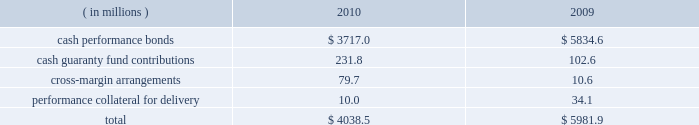Anticipated or possible short-term cash needs , prevailing interest rates , our investment policy and alternative investment choices .
A majority of our cash and cash equivalents balance is invested in money market mutual funds that invest only in u.s .
Treasury securities or u.s .
Government agency securities .
Our exposure to risk is minimal given the nature of the investments .
Our practice is to have our pension plan 100% ( 100 % ) funded at each year end on a projected benefit obligation basis , while also satisfying any minimum required contribution and obtaining the maximum tax deduction .
Based on our actuarial projections , we estimate that a $ 14.1 million contribution in 2011 will allow us to meet our funding goal .
However , the amount of the actual contribution is contingent on the actual rate of return on our plan assets during 2011 and the december 31 , 2011 discount rate .
Net current deferred tax assets of $ 18.3 million and $ 23.8 million are included in other current assets at december 31 , 2010 and 2009 , respectively .
Total net current deferred tax assets include unrealized losses , stock- based compensation and accrued expenses .
Net long-term deferred tax liabilities were $ 7.8 billion and $ 7.6 billion at december 31 , 2010 and 2009 , respectively .
Net deferred tax liabilities are principally the result of purchase accounting for intangible assets in our various mergers including cbot holdings and nymex holdings .
We have a long-term deferred tax asset of $ 145.7 million included within our domestic long-term deferred tax liability .
This deferred tax asset is for an unrealized capital loss incurred in brazil related to our investment in bm&fbovespa .
As of december 31 , 2010 , we do not believe that we currently meet the more-likely-than-not threshold that would allow us to fully realize the value of the unrealized capital loss .
As a result , a partial valuation allowance of $ 64.4 million has been provided for the amount of the unrealized capital loss that exceeds potential capital gains that could be used to offset the capital loss in future periods .
We also have a long-term deferred tax asset related to brazilian taxes of $ 125.3 million for an unrealized capital loss incurred in brazil related to our investment in bm&fbovespa .
A full valuation allowance of $ 125.3 million has been provided because we do not believe that we currently meet the more-likely-than-not threshold that would allow us to realize the value of the unrealized capital loss in brazil in the future .
Valuation allowances of $ 49.4 million have also been provided for additional unrealized capital losses on various other investments .
Net long-term deferred tax assets also include a $ 19.3 million deferred tax asset for foreign net operating losses related to swapstream .
Our assessment at december 31 , 2010 was that we did not currently meet the more-likely- than-not threshold that would allow us to realize the value of acquired and accumulated foreign net operating losses in the future .
As a result , the $ 19.3 million deferred tax assets arising from these net operating losses have been fully reserved .
Each clearing firm is required to deposit and maintain specified performance bond collateral .
Performance bond requirements are determined by parameters established by the risk management department of the clearing house and may fluctuate over time .
We accept a variety of collateral to satisfy performance bond requirements .
Cash performance bonds and guaranty fund contributions are included in our consolidated balance sheets .
Clearing firm deposits , other than those retained in the form of cash , are not included in our consolidated balance sheets .
The balances in cash performance bonds and guaranty fund contributions may fluctuate significantly over time .
Cash performance bonds and guaranty fund contributions consisted of the following at december 31: .

What was the ratio of net long-term deferred tax liabilities in 2010 compared to 2009? 
Computations: (7.8 / 7.6)
Answer: 1.02632. Anticipated or possible short-term cash needs , prevailing interest rates , our investment policy and alternative investment choices .
A majority of our cash and cash equivalents balance is invested in money market mutual funds that invest only in u.s .
Treasury securities or u.s .
Government agency securities .
Our exposure to risk is minimal given the nature of the investments .
Our practice is to have our pension plan 100% ( 100 % ) funded at each year end on a projected benefit obligation basis , while also satisfying any minimum required contribution and obtaining the maximum tax deduction .
Based on our actuarial projections , we estimate that a $ 14.1 million contribution in 2011 will allow us to meet our funding goal .
However , the amount of the actual contribution is contingent on the actual rate of return on our plan assets during 2011 and the december 31 , 2011 discount rate .
Net current deferred tax assets of $ 18.3 million and $ 23.8 million are included in other current assets at december 31 , 2010 and 2009 , respectively .
Total net current deferred tax assets include unrealized losses , stock- based compensation and accrued expenses .
Net long-term deferred tax liabilities were $ 7.8 billion and $ 7.6 billion at december 31 , 2010 and 2009 , respectively .
Net deferred tax liabilities are principally the result of purchase accounting for intangible assets in our various mergers including cbot holdings and nymex holdings .
We have a long-term deferred tax asset of $ 145.7 million included within our domestic long-term deferred tax liability .
This deferred tax asset is for an unrealized capital loss incurred in brazil related to our investment in bm&fbovespa .
As of december 31 , 2010 , we do not believe that we currently meet the more-likely-than-not threshold that would allow us to fully realize the value of the unrealized capital loss .
As a result , a partial valuation allowance of $ 64.4 million has been provided for the amount of the unrealized capital loss that exceeds potential capital gains that could be used to offset the capital loss in future periods .
We also have a long-term deferred tax asset related to brazilian taxes of $ 125.3 million for an unrealized capital loss incurred in brazil related to our investment in bm&fbovespa .
A full valuation allowance of $ 125.3 million has been provided because we do not believe that we currently meet the more-likely-than-not threshold that would allow us to realize the value of the unrealized capital loss in brazil in the future .
Valuation allowances of $ 49.4 million have also been provided for additional unrealized capital losses on various other investments .
Net long-term deferred tax assets also include a $ 19.3 million deferred tax asset for foreign net operating losses related to swapstream .
Our assessment at december 31 , 2010 was that we did not currently meet the more-likely- than-not threshold that would allow us to realize the value of acquired and accumulated foreign net operating losses in the future .
As a result , the $ 19.3 million deferred tax assets arising from these net operating losses have been fully reserved .
Each clearing firm is required to deposit and maintain specified performance bond collateral .
Performance bond requirements are determined by parameters established by the risk management department of the clearing house and may fluctuate over time .
We accept a variety of collateral to satisfy performance bond requirements .
Cash performance bonds and guaranty fund contributions are included in our consolidated balance sheets .
Clearing firm deposits , other than those retained in the form of cash , are not included in our consolidated balance sheets .
The balances in cash performance bonds and guaranty fund contributions may fluctuate significantly over time .
Cash performance bonds and guaranty fund contributions consisted of the following at december 31: .

For 2010 , what was the net deferred tax liability? 
Computations: (((7.8 * 1000000) * 1000) - (18.3 * 1000000))
Answer: 7781700000.0. 